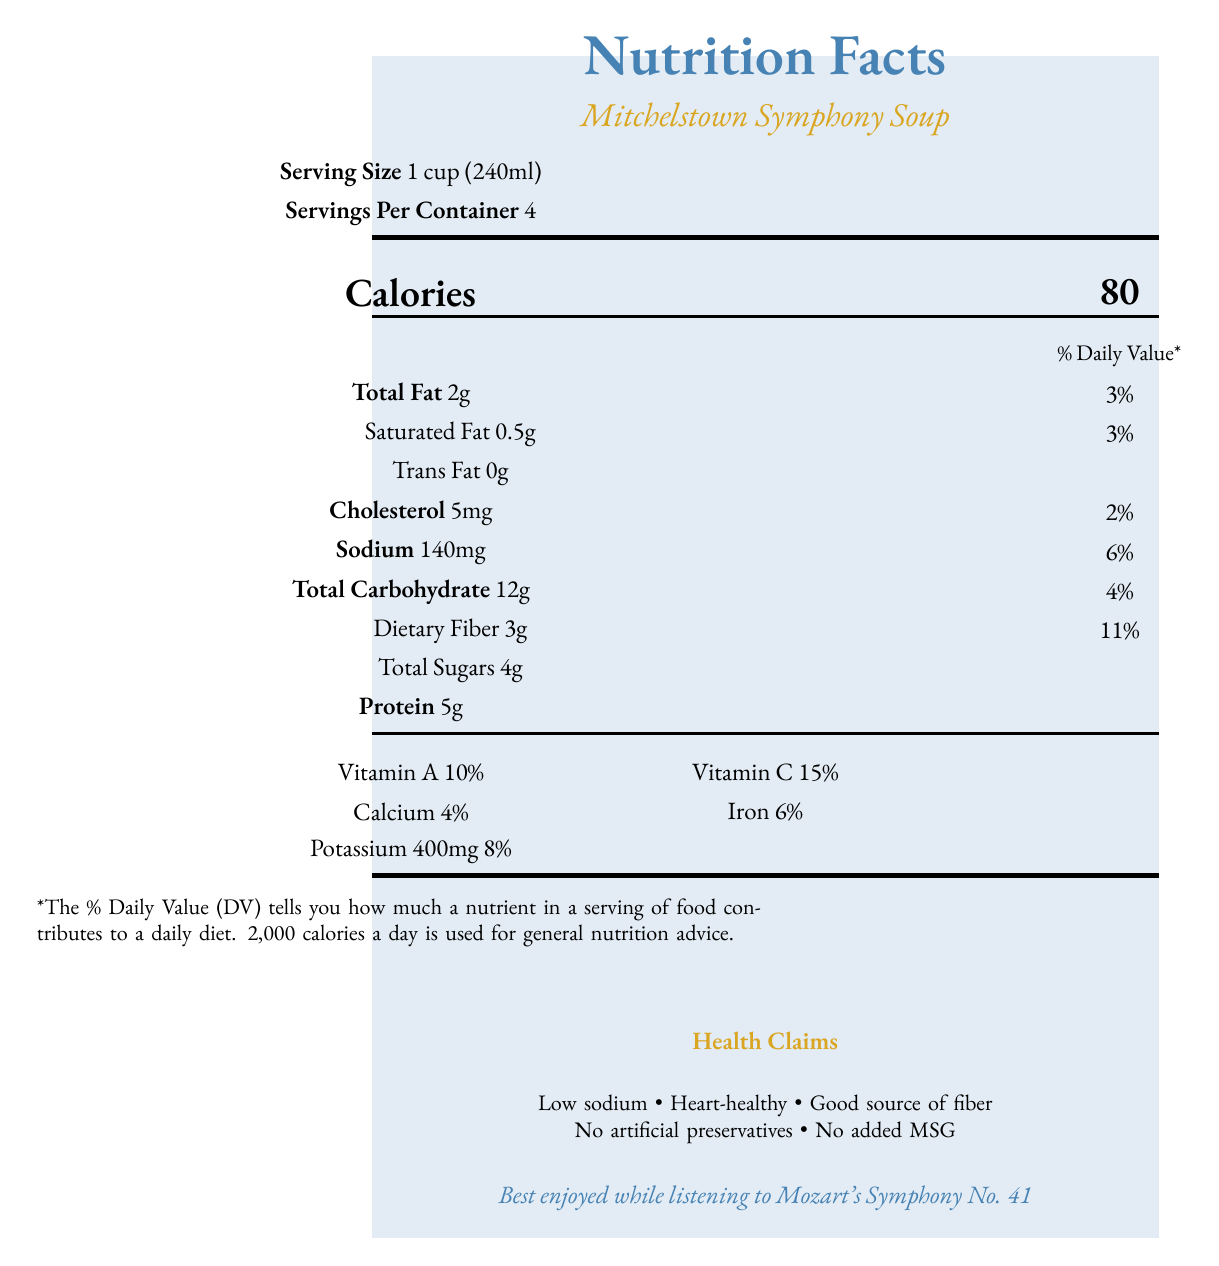what is the serving size for Mitchelstown Symphony Soup? The serving size is explicitly stated under the serving information as "Serving Size 1 cup (240ml)".
Answer: 1 cup (240ml) how many calories are in a single serving of Mitchelstown Symphony Soup? The calorie information is presented prominently, showing each serving contains 80 calories.
Answer: 80 what is the total fat content per serving? The total fat content per serving is listed as "Total Fat 2g."
Answer: 2g What are the vitamins mentioned in the Nutrition Facts Label? The vitamins listed are "Vitamin A 10%" and "Vitamin C 15%."
Answer: Vitamin A and Vitamin C How much sodium does the soup contain per serving? The sodium content per serving is listed as "Sodium 140mg."
Answer: 140mg Which of the following ingredients is NOT in the Mitchelstown Symphony Soup?
A. Organic carrots 
B. Organic onions 
C. Organic potatoes 
D. Free-range chicken The ingredients list includes organic carrots, organic onions, and free-range chicken, but not organic potatoes.
Answer: C What should the noise level be while enjoying the soup according to the document?
I. Loud
II. Quiet 
III. Moderate 
IV. Very loud The document states "Quiet sipping recommended for optimal enjoyment."
Answer: II. Quiet True or False: The soup contains artificial preservatives. The health claims clearly state "No artificial preservatives."
Answer: False Summarize the main idea of the document. The document highlights the nutritional details, ingredients, and health benefits of Mitchelstown Symphony Soup, along with local sourcing and a recommendation for a quiet dining atmosphere. It emphasizes the soup's qualities as a low-sodium, heart-healthy option without artificial preservatives.
Answer: The document provides the nutrition facts, ingredients, allergens, health claims, and other relevant information for Mitchelstown Symphony Soup, a low-sodium, heart-healthy soup made by Galtee Artisan Foods. The soup emphasizes its natural ingredients, with a focus on low sodium, heart health, and the absence of artificial preservatives and MSG. The vegetables used are locally sourced, and the document even includes a suggested musical pairing for an optimal dining experience. What percentage of the daily value for dietary fiber does one serving provide? The document lists "Dietary Fiber 3g" and corresponds this to "11%."
Answer: 11% Does the soup contain added MSG? The health claims include "No added MSG."
Answer: No What is the amount of potassium per serving, and what percentage of daily value does it represent? The document states "Potassium 400mg 8%."
Answer: 400mg, 8% What is the company value promoted by Galtee Artisan Foods according to the document? The company values section mentions "Supporting local agriculture and promoting a peaceful dining experience."
Answer: Supporting local agriculture and promoting a peaceful dining experience How many grams of trans fat are in each serving? The document lists "Trans Fat 0g."
Answer: 0g Which vegetables are explicitly sourced from Mitchelstown Community Gardens? The document states that "All vegetables sourced from Mitchelstown Community Gardens."
Answer: All vegetables Where should the soup be stored? The storage instructions specify to "Keep refrigerated."
Answer: Keep refrigerated Is the packaging of the soup environmentally friendly? The document mentions "Packaging made from 100% recycled materials."
Answer: Yes How many servings are in one container of Mitchelstown Symphony Soup? The serving information section indicates "Servings Per Container 4."
Answer: 4 What type of music is recommended to pair with this soup? The musical pairing suggests the soup is "Best enjoyed while listening to Mozart's Symphony No. 41."
Answer: Mozart's Symphony No. 41 When should the soup be consumed after opening? The storage instructions advise to "Consume within 5 days of opening."
Answer: Within 5 days What is the percentage daily value for calcium per serving? The document lists "Calcium 4%" in the vitamins and minerals section.
Answer: 4% What are the preparation instructions for the soup? The preparation instructions state "Gently heat on stovetop or microwave. Do not boil."
Answer: Gently heat on stovetop or microwave. Do not boil. Do we know the price of the Mitchelstown Symphony Soup? The price is not mentioned in the document, so this information cannot be determined.
Answer: Cannot be determined 